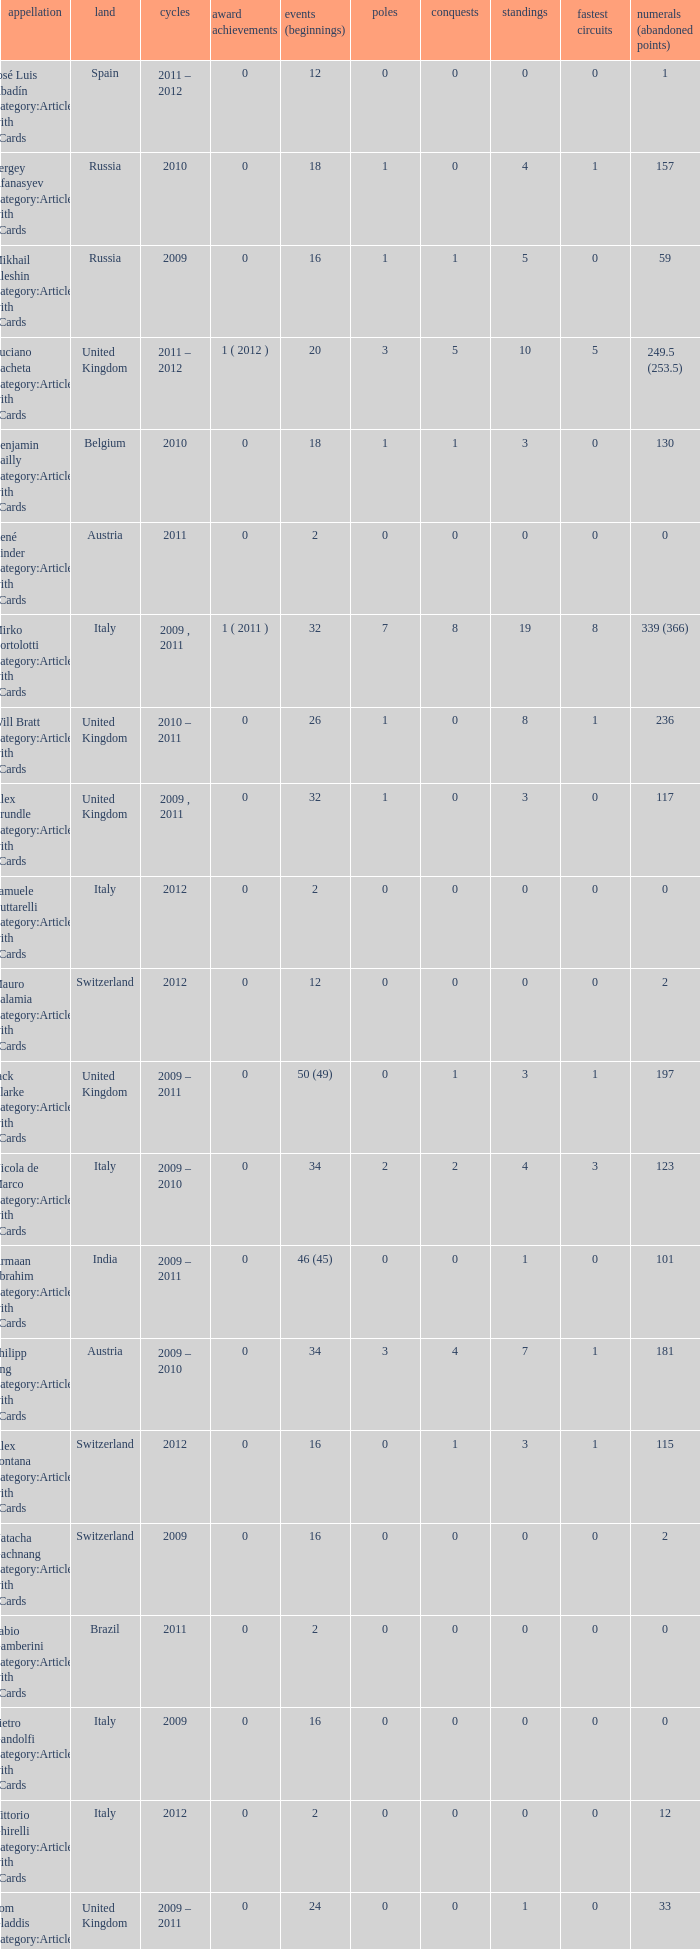What were the starts when the points dropped 18? 8.0. 